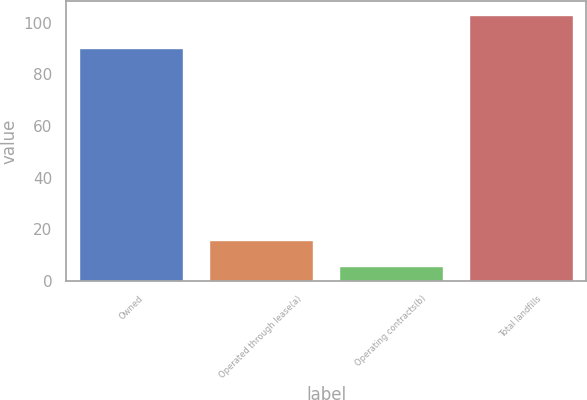Convert chart. <chart><loc_0><loc_0><loc_500><loc_500><bar_chart><fcel>Owned<fcel>Operated through lease(a)<fcel>Operating contracts(b)<fcel>Total landfills<nl><fcel>90<fcel>15.7<fcel>6<fcel>103<nl></chart> 